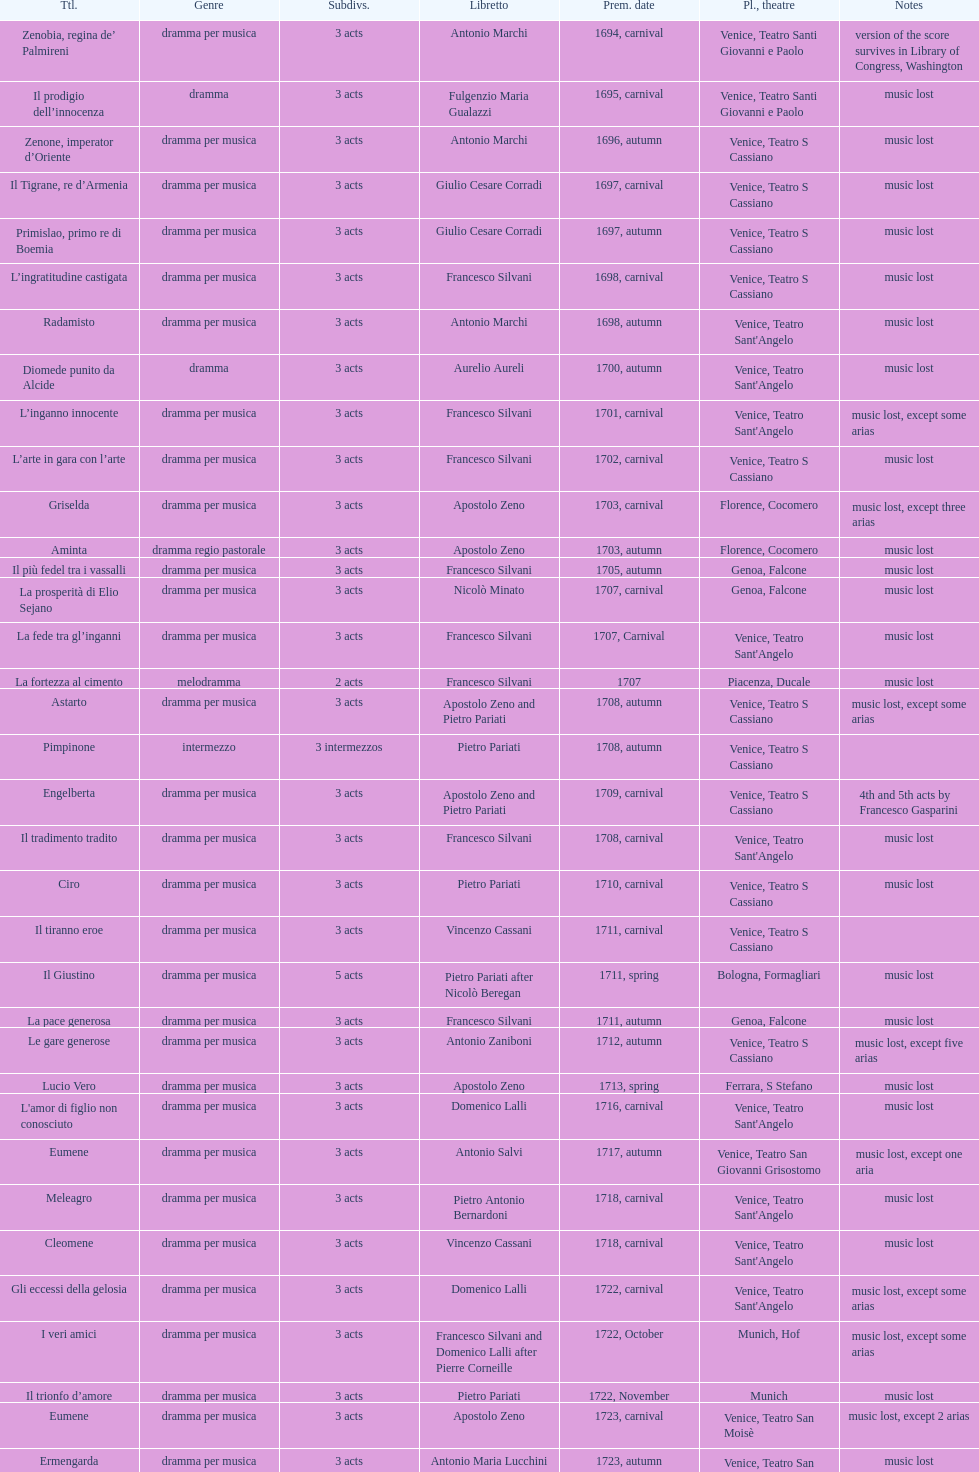Which opera has at least 5 acts? Il Giustino. Can you parse all the data within this table? {'header': ['Ttl.', 'Genre', 'Sub\xaddivs.', 'Libretto', 'Prem. date', 'Pl., theatre', 'Notes'], 'rows': [['Zenobia, regina de’ Palmireni', 'dramma per musica', '3 acts', 'Antonio Marchi', '1694, carnival', 'Venice, Teatro Santi Giovanni e Paolo', 'version of the score survives in Library of Congress, Washington'], ['Il prodigio dell’innocenza', 'dramma', '3 acts', 'Fulgenzio Maria Gualazzi', '1695, carnival', 'Venice, Teatro Santi Giovanni e Paolo', 'music lost'], ['Zenone, imperator d’Oriente', 'dramma per musica', '3 acts', 'Antonio Marchi', '1696, autumn', 'Venice, Teatro S Cassiano', 'music lost'], ['Il Tigrane, re d’Armenia', 'dramma per musica', '3 acts', 'Giulio Cesare Corradi', '1697, carnival', 'Venice, Teatro S Cassiano', 'music lost'], ['Primislao, primo re di Boemia', 'dramma per musica', '3 acts', 'Giulio Cesare Corradi', '1697, autumn', 'Venice, Teatro S Cassiano', 'music lost'], ['L’ingratitudine castigata', 'dramma per musica', '3 acts', 'Francesco Silvani', '1698, carnival', 'Venice, Teatro S Cassiano', 'music lost'], ['Radamisto', 'dramma per musica', '3 acts', 'Antonio Marchi', '1698, autumn', "Venice, Teatro Sant'Angelo", 'music lost'], ['Diomede punito da Alcide', 'dramma', '3 acts', 'Aurelio Aureli', '1700, autumn', "Venice, Teatro Sant'Angelo", 'music lost'], ['L’inganno innocente', 'dramma per musica', '3 acts', 'Francesco Silvani', '1701, carnival', "Venice, Teatro Sant'Angelo", 'music lost, except some arias'], ['L’arte in gara con l’arte', 'dramma per musica', '3 acts', 'Francesco Silvani', '1702, carnival', 'Venice, Teatro S Cassiano', 'music lost'], ['Griselda', 'dramma per musica', '3 acts', 'Apostolo Zeno', '1703, carnival', 'Florence, Cocomero', 'music lost, except three arias'], ['Aminta', 'dramma regio pastorale', '3 acts', 'Apostolo Zeno', '1703, autumn', 'Florence, Cocomero', 'music lost'], ['Il più fedel tra i vassalli', 'dramma per musica', '3 acts', 'Francesco Silvani', '1705, autumn', 'Genoa, Falcone', 'music lost'], ['La prosperità di Elio Sejano', 'dramma per musica', '3 acts', 'Nicolò Minato', '1707, carnival', 'Genoa, Falcone', 'music lost'], ['La fede tra gl’inganni', 'dramma per musica', '3 acts', 'Francesco Silvani', '1707, Carnival', "Venice, Teatro Sant'Angelo", 'music lost'], ['La fortezza al cimento', 'melodramma', '2 acts', 'Francesco Silvani', '1707', 'Piacenza, Ducale', 'music lost'], ['Astarto', 'dramma per musica', '3 acts', 'Apostolo Zeno and Pietro Pariati', '1708, autumn', 'Venice, Teatro S Cassiano', 'music lost, except some arias'], ['Pimpinone', 'intermezzo', '3 intermezzos', 'Pietro Pariati', '1708, autumn', 'Venice, Teatro S Cassiano', ''], ['Engelberta', 'dramma per musica', '3 acts', 'Apostolo Zeno and Pietro Pariati', '1709, carnival', 'Venice, Teatro S Cassiano', '4th and 5th acts by Francesco Gasparini'], ['Il tradimento tradito', 'dramma per musica', '3 acts', 'Francesco Silvani', '1708, carnival', "Venice, Teatro Sant'Angelo", 'music lost'], ['Ciro', 'dramma per musica', '3 acts', 'Pietro Pariati', '1710, carnival', 'Venice, Teatro S Cassiano', 'music lost'], ['Il tiranno eroe', 'dramma per musica', '3 acts', 'Vincenzo Cassani', '1711, carnival', 'Venice, Teatro S Cassiano', ''], ['Il Giustino', 'dramma per musica', '5 acts', 'Pietro Pariati after Nicolò Beregan', '1711, spring', 'Bologna, Formagliari', 'music lost'], ['La pace generosa', 'dramma per musica', '3 acts', 'Francesco Silvani', '1711, autumn', 'Genoa, Falcone', 'music lost'], ['Le gare generose', 'dramma per musica', '3 acts', 'Antonio Zaniboni', '1712, autumn', 'Venice, Teatro S Cassiano', 'music lost, except five arias'], ['Lucio Vero', 'dramma per musica', '3 acts', 'Apostolo Zeno', '1713, spring', 'Ferrara, S Stefano', 'music lost'], ["L'amor di figlio non conosciuto", 'dramma per musica', '3 acts', 'Domenico Lalli', '1716, carnival', "Venice, Teatro Sant'Angelo", 'music lost'], ['Eumene', 'dramma per musica', '3 acts', 'Antonio Salvi', '1717, autumn', 'Venice, Teatro San Giovanni Grisostomo', 'music lost, except one aria'], ['Meleagro', 'dramma per musica', '3 acts', 'Pietro Antonio Bernardoni', '1718, carnival', "Venice, Teatro Sant'Angelo", 'music lost'], ['Cleomene', 'dramma per musica', '3 acts', 'Vincenzo Cassani', '1718, carnival', "Venice, Teatro Sant'Angelo", 'music lost'], ['Gli eccessi della gelosia', 'dramma per musica', '3 acts', 'Domenico Lalli', '1722, carnival', "Venice, Teatro Sant'Angelo", 'music lost, except some arias'], ['I veri amici', 'dramma per musica', '3 acts', 'Francesco Silvani and Domenico Lalli after Pierre Corneille', '1722, October', 'Munich, Hof', 'music lost, except some arias'], ['Il trionfo d’amore', 'dramma per musica', '3 acts', 'Pietro Pariati', '1722, November', 'Munich', 'music lost'], ['Eumene', 'dramma per musica', '3 acts', 'Apostolo Zeno', '1723, carnival', 'Venice, Teatro San Moisè', 'music lost, except 2 arias'], ['Ermengarda', 'dramma per musica', '3 acts', 'Antonio Maria Lucchini', '1723, autumn', 'Venice, Teatro San Moisè', 'music lost'], ['Antigono, tutore di Filippo, re di Macedonia', 'tragedia', '5 acts', 'Giovanni Piazzon', '1724, carnival', 'Venice, Teatro San Moisè', '5th act by Giovanni Porta, music lost'], ['Scipione nelle Spagne', 'dramma per musica', '3 acts', 'Apostolo Zeno', '1724, Ascension', 'Venice, Teatro San Samuele', 'music lost'], ['Laodice', 'dramma per musica', '3 acts', 'Angelo Schietti', '1724, autumn', 'Venice, Teatro San Moisè', 'music lost, except 2 arias'], ['Didone abbandonata', 'tragedia', '3 acts', 'Metastasio', '1725, carnival', 'Venice, Teatro S Cassiano', 'music lost'], ["L'impresario delle Isole Canarie", 'intermezzo', '2 acts', 'Metastasio', '1725, carnival', 'Venice, Teatro S Cassiano', 'music lost'], ['Alcina delusa da Ruggero', 'dramma per musica', '3 acts', 'Antonio Marchi', '1725, autumn', 'Venice, Teatro S Cassiano', 'music lost'], ['I rivali generosi', 'dramma per musica', '3 acts', 'Apostolo Zeno', '1725', 'Brescia, Nuovo', ''], ['La Statira', 'dramma per musica', '3 acts', 'Apostolo Zeno and Pietro Pariati', '1726, Carnival', 'Rome, Teatro Capranica', ''], ['Malsazio e Fiammetta', 'intermezzo', '', '', '1726, Carnival', 'Rome, Teatro Capranica', ''], ['Il trionfo di Armida', 'dramma per musica', '3 acts', 'Girolamo Colatelli after Torquato Tasso', '1726, autumn', 'Venice, Teatro San Moisè', 'music lost'], ['L’incostanza schernita', 'dramma comico-pastorale', '3 acts', 'Vincenzo Cassani', '1727, Ascension', 'Venice, Teatro San Samuele', 'music lost, except some arias'], ['Le due rivali in amore', 'dramma per musica', '3 acts', 'Aurelio Aureli', '1728, autumn', 'Venice, Teatro San Moisè', 'music lost'], ['Il Satrapone', 'intermezzo', '', 'Salvi', '1729', 'Parma, Omodeo', ''], ['Li stratagemmi amorosi', 'dramma per musica', '3 acts', 'F Passerini', '1730, carnival', 'Venice, Teatro San Moisè', 'music lost'], ['Elenia', 'dramma per musica', '3 acts', 'Luisa Bergalli', '1730, carnival', "Venice, Teatro Sant'Angelo", 'music lost'], ['Merope', 'dramma', '3 acts', 'Apostolo Zeno', '1731, autumn', 'Prague, Sporck Theater', 'mostly by Albinoni, music lost'], ['Il più infedel tra gli amanti', 'dramma per musica', '3 acts', 'Angelo Schietti', '1731, autumn', 'Treviso, Dolphin', 'music lost'], ['Ardelinda', 'dramma', '3 acts', 'Bartolomeo Vitturi', '1732, autumn', "Venice, Teatro Sant'Angelo", 'music lost, except five arias'], ['Candalide', 'dramma per musica', '3 acts', 'Bartolomeo Vitturi', '1734, carnival', "Venice, Teatro Sant'Angelo", 'music lost'], ['Artamene', 'dramma per musica', '3 acts', 'Bartolomeo Vitturi', '1741, carnival', "Venice, Teatro Sant'Angelo", 'music lost']]} 